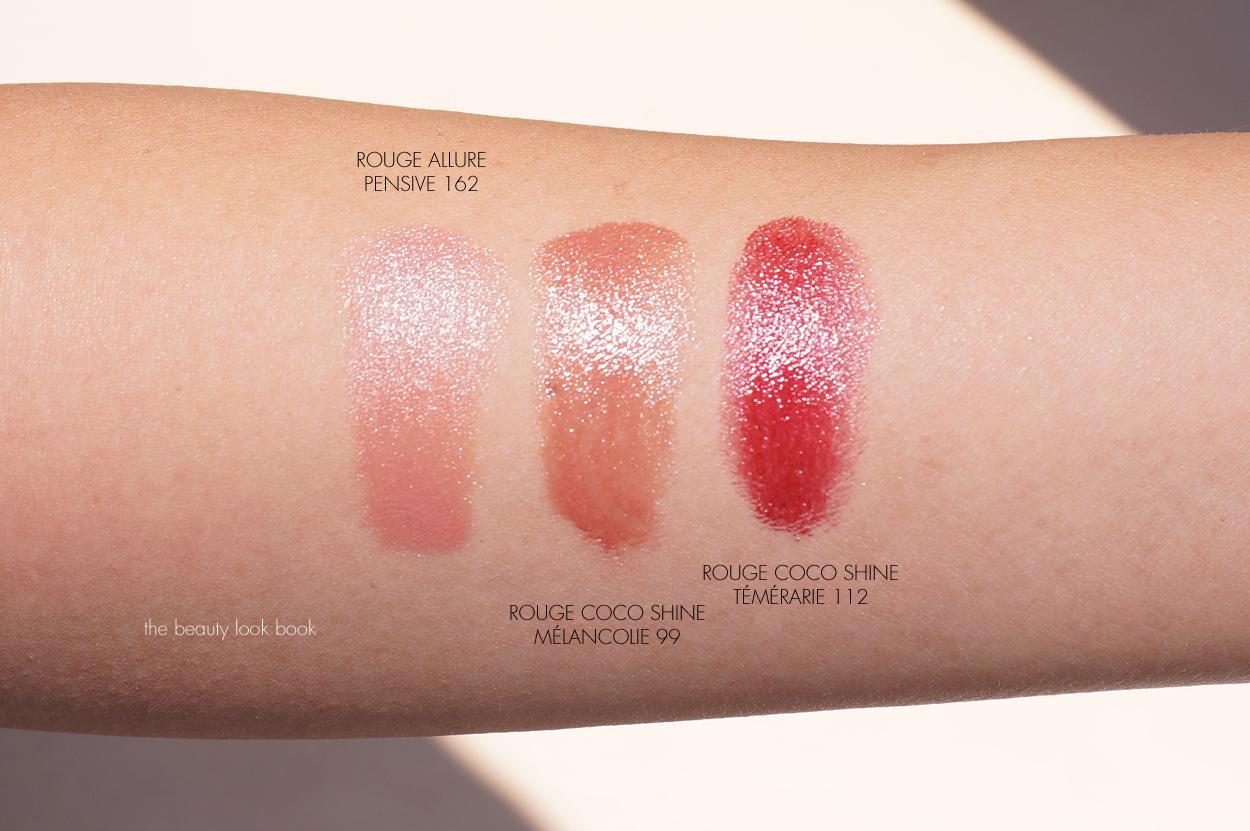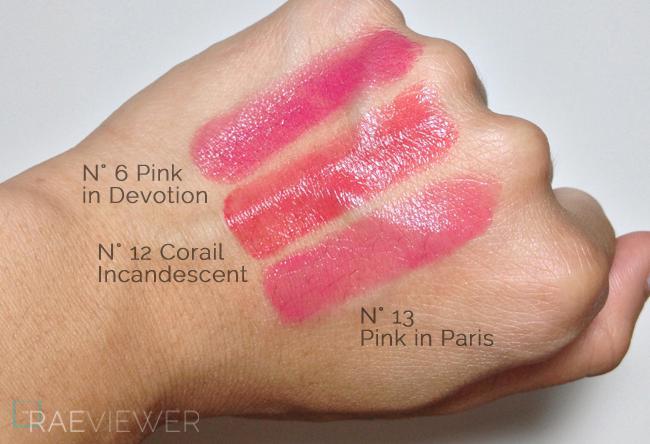The first image is the image on the left, the second image is the image on the right. Assess this claim about the two images: "There are two lipstick stripes on the skin in one of the images.". Correct or not? Answer yes or no. No. The first image is the image on the left, the second image is the image on the right. For the images displayed, is the sentence "An image shows exactly two lipstick smears on a closed fist with pale skin." factually correct? Answer yes or no. No. 